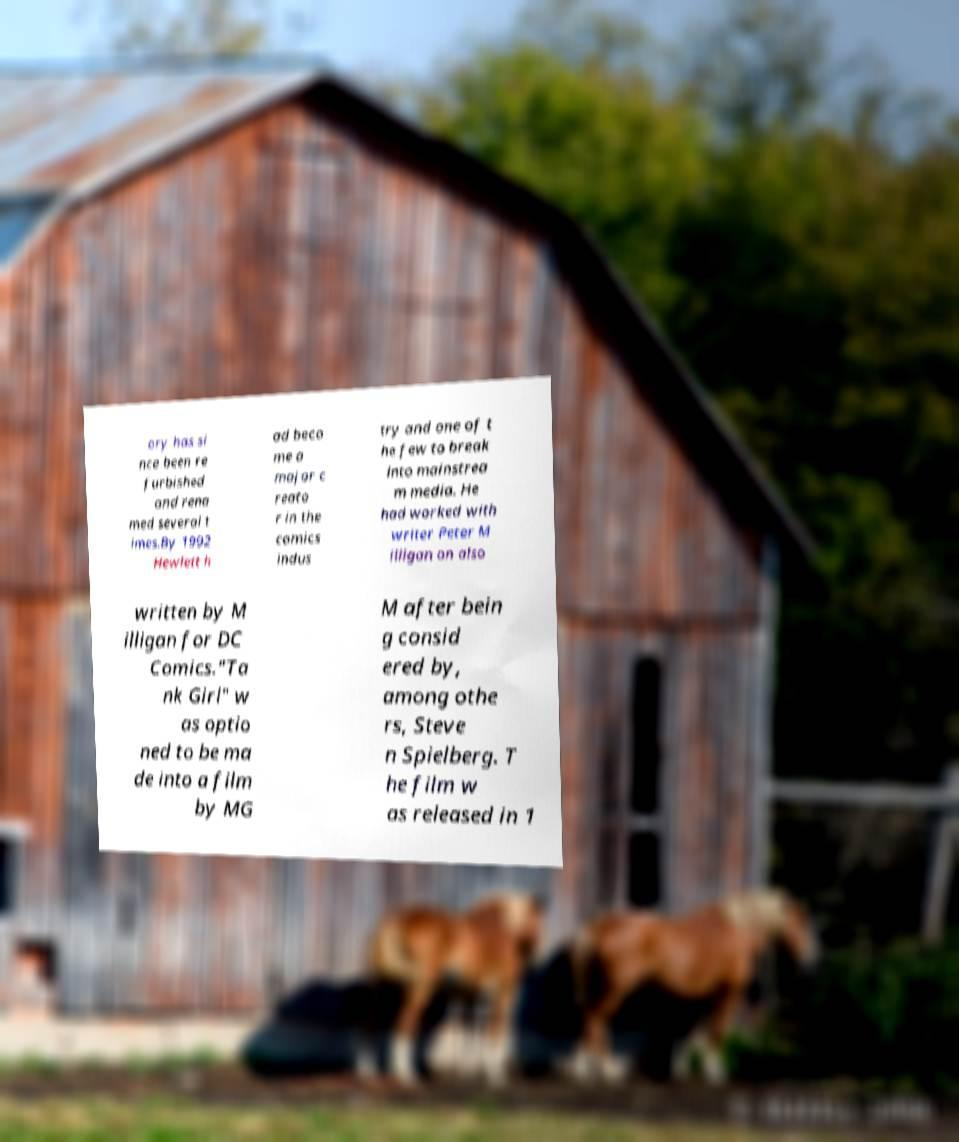For documentation purposes, I need the text within this image transcribed. Could you provide that? ory has si nce been re furbished and rena med several t imes.By 1992 Hewlett h ad beco me a major c reato r in the comics indus try and one of t he few to break into mainstrea m media. He had worked with writer Peter M illigan on also written by M illigan for DC Comics."Ta nk Girl" w as optio ned to be ma de into a film by MG M after bein g consid ered by, among othe rs, Steve n Spielberg. T he film w as released in 1 